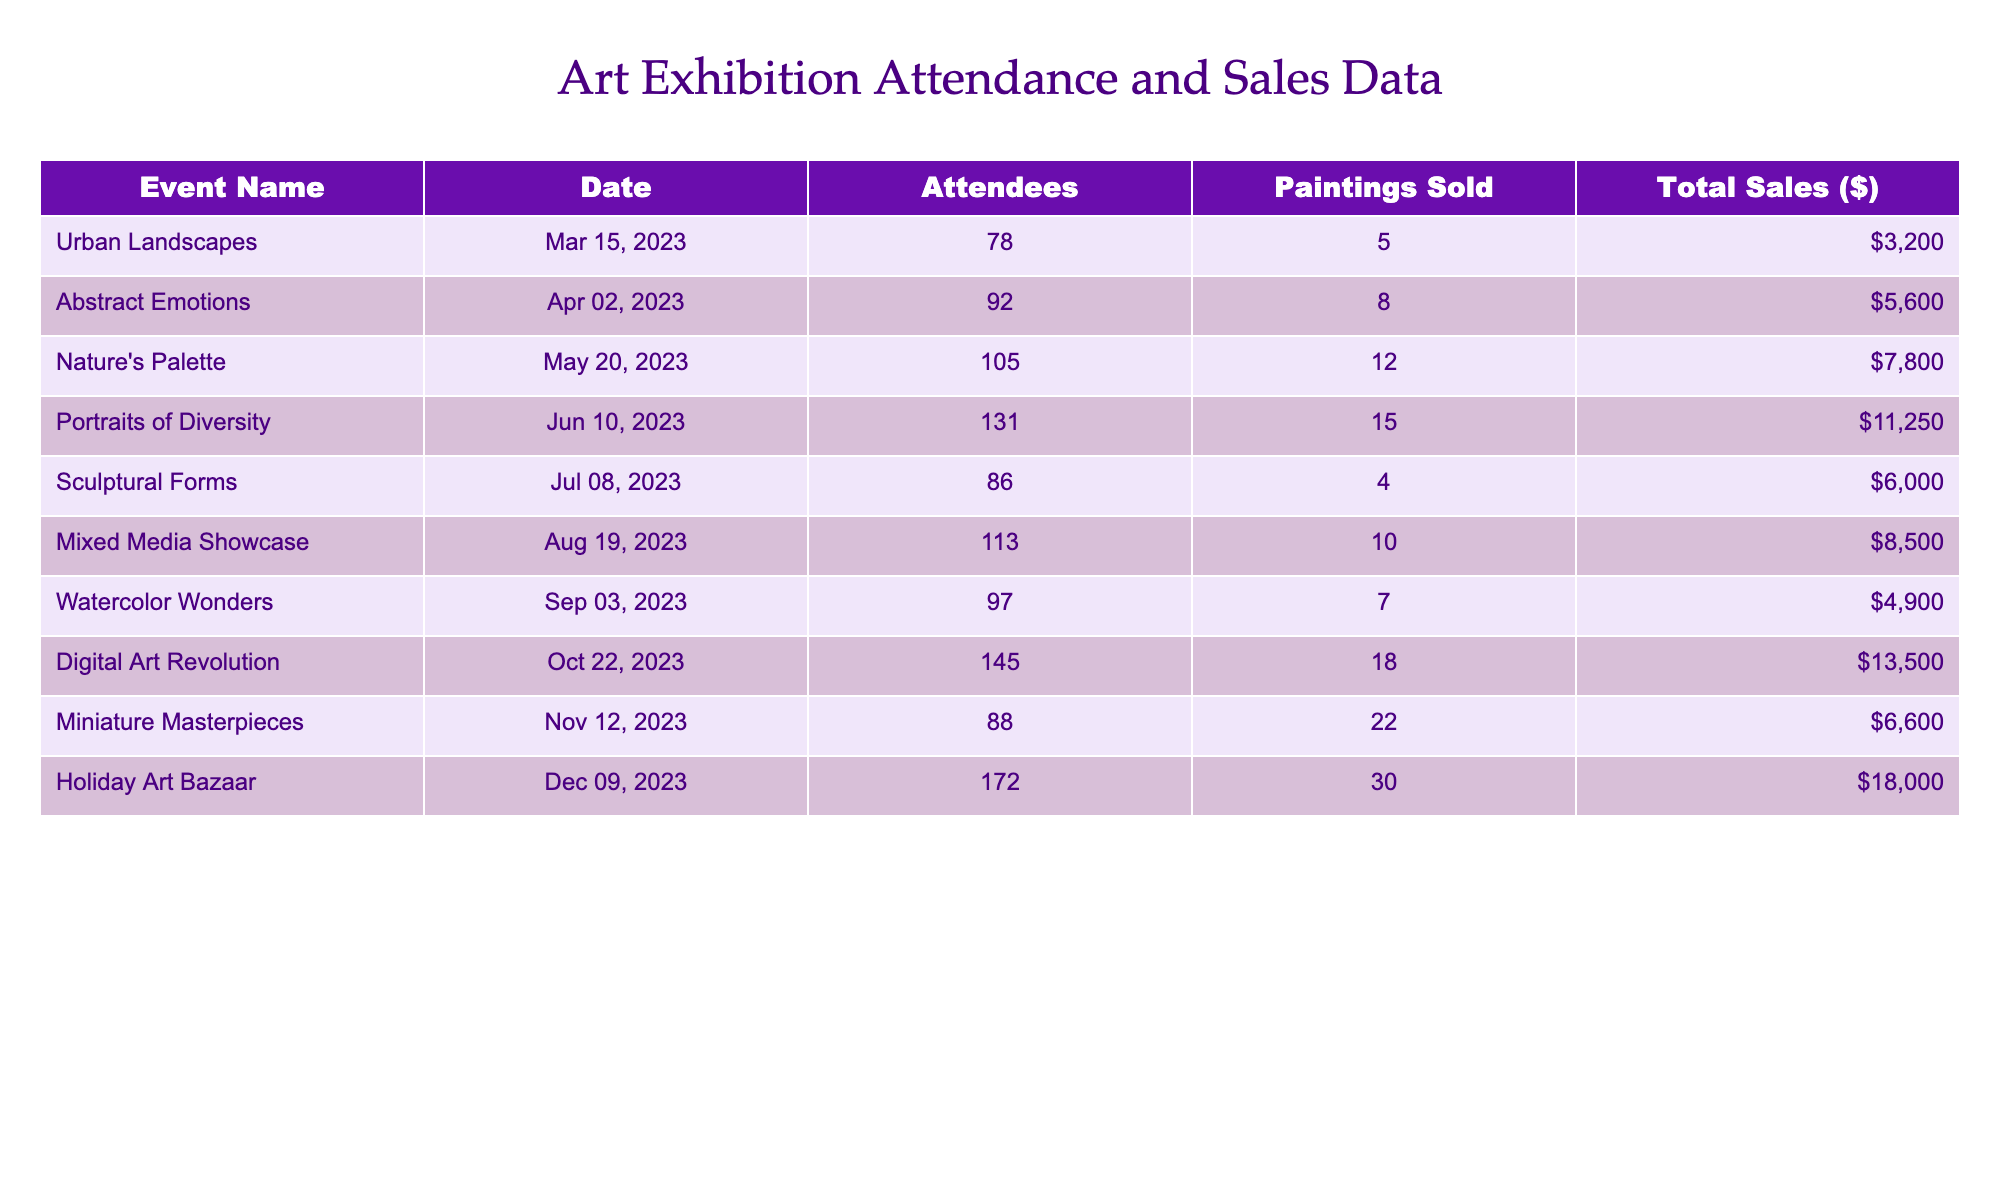What was the total attendance across all events? To find the total attendance, we add up the 'Attendees' column: 78 + 92 + 105 + 131 + 86 + 113 + 97 + 145 + 88 + 172 = 1,105.
Answer: 1,105 Which event had the highest sales? By comparing the 'Total Sales ($)' column, "Holiday Art Bazaar" has the highest value at $18,000.
Answer: "Holiday Art Bazaar" How many paintings were sold during "Digital Art Revolution"? The number of paintings sold in the "Digital Art Revolution" event can be found in the 'Paintings Sold' column, which is 18.
Answer: 18 What is the average number of attendees per event? To calculate the average, sum the attendees (1,105) and divide by the number of events (10): 1,105 / 10 = 110.5.
Answer: 110.5 Was there an event with more than 140 attendees? "Digital Art Revolution" and "Holiday Art Bazaar" had more than 140 attendees (145 and 172, respectively). So, the answer is yes.
Answer: Yes How much did "Nature's Palette" earn compared to "Sculptural Forms"? "Nature's Palette" earned $7,800, and "Sculptural Forms" earned $6,000. The difference is $7,800 - $6,000 = $1,800 more for "Nature's Palette."
Answer: $1,800 What percentage of total sales does the "Miniature Masterpieces" event represent? First, find total sales: $32,700. "Miniature Masterpieces" sales are $6,600. Calculate percentage: ($6,600 / $32,700) * 100 ≈ 20.1%.
Answer: 20.1% Which event had the least number of paintings sold? By observing the 'Paintings Sold' column, "Sculptural Forms" had the least at 4 paintings sold.
Answer: "Sculptural Forms" What is the total number of paintings sold across all events? Sum all values in the 'Paintings Sold' column: 5 + 8 + 12 + 15 + 4 + 10 + 7 + 18 + 22 + 30 = 132.
Answer: 132 How much were the total sales for the event with the least attendance? The event with the least attendance, "Urban Landscapes" had total sales of $3,200.
Answer: $3,200 